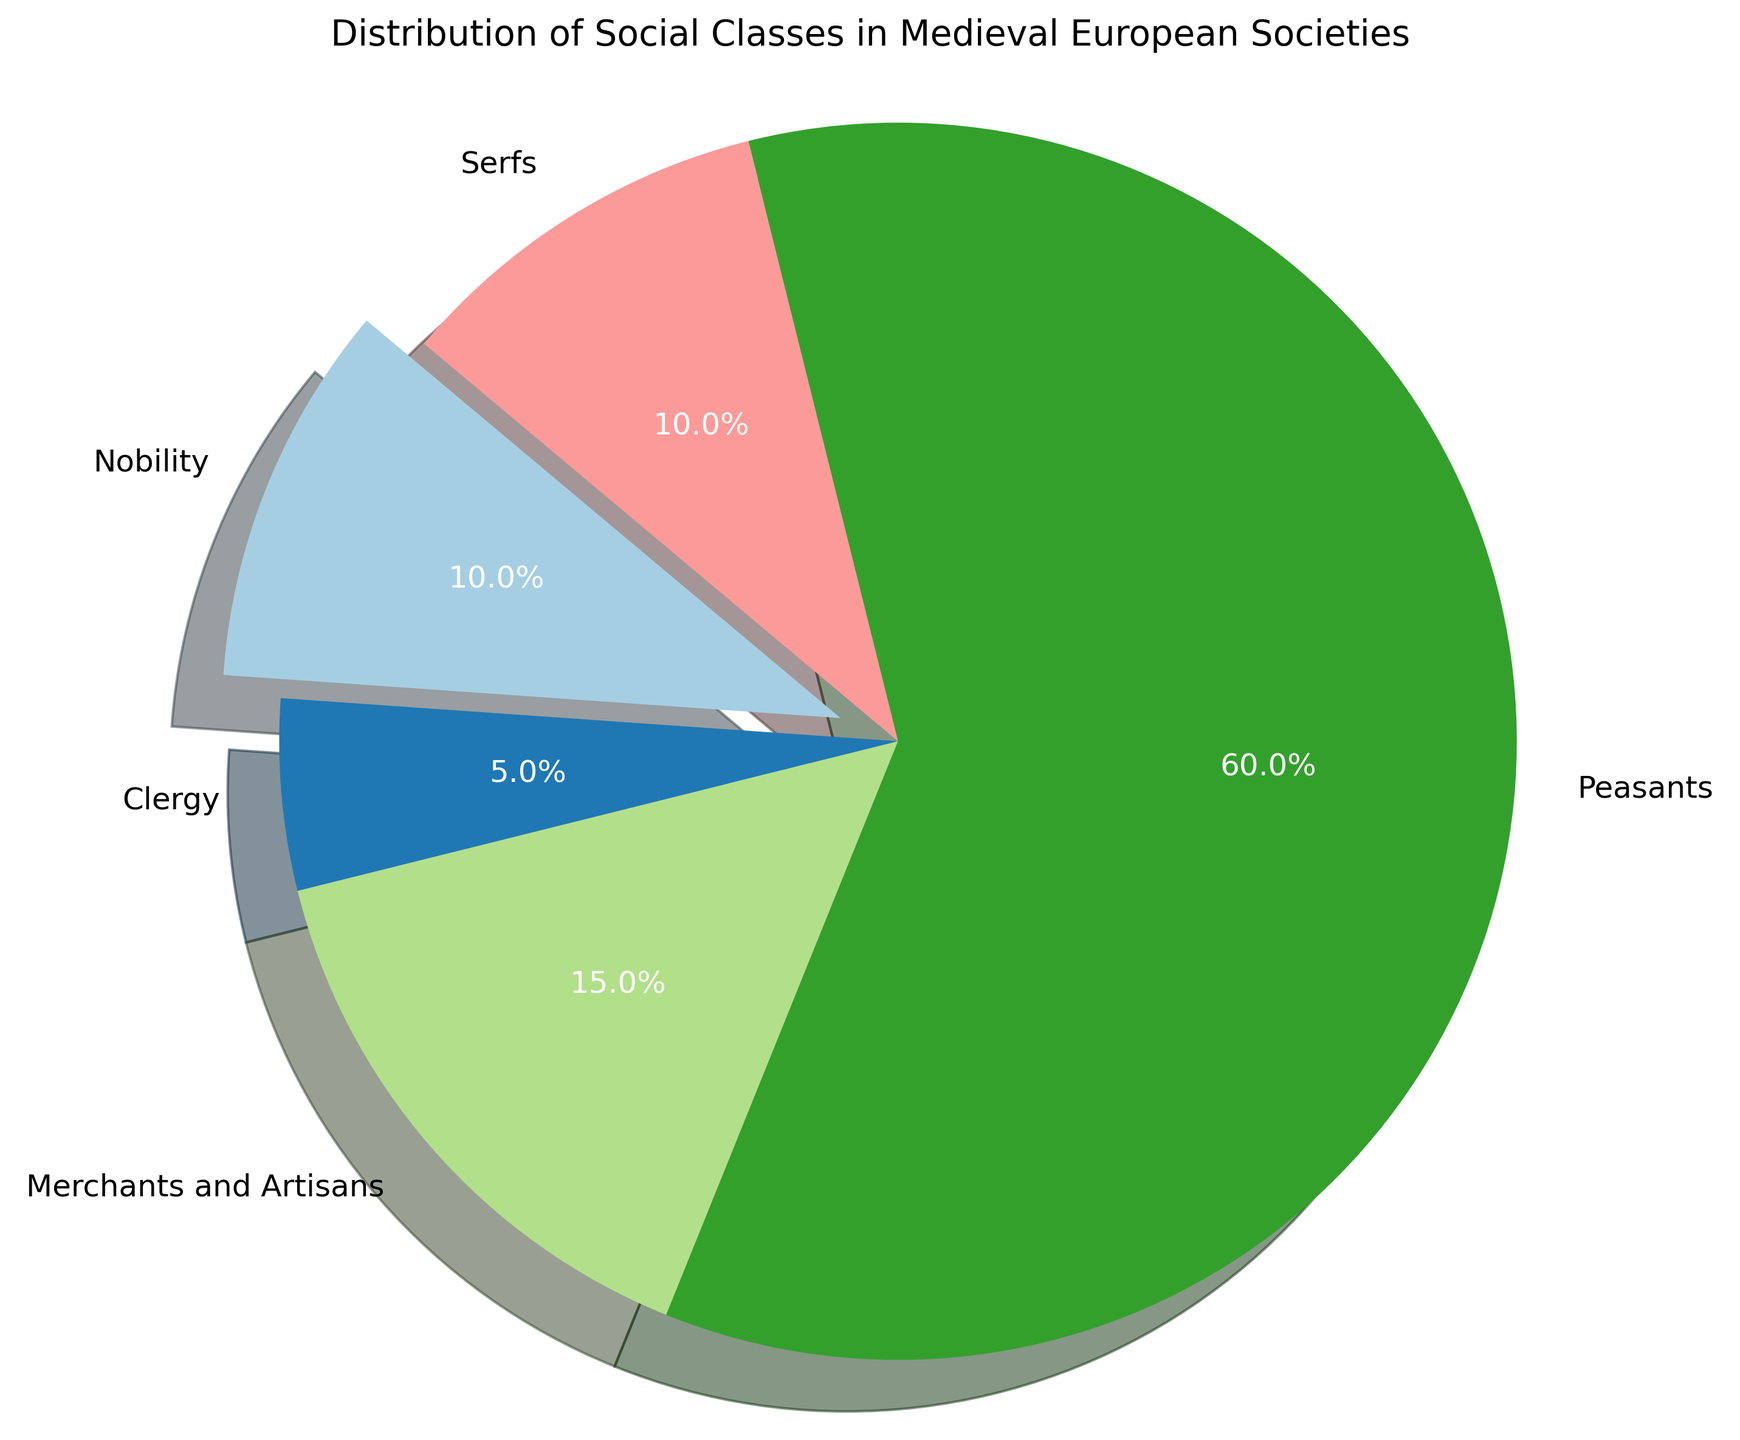Which social class has the highest percentage in the distribution? The figure shows that the 'Peasants' class occupies the largest portion of the pie chart. This indicates that they have the highest percentage in the distribution.
Answer: Peasants What is the combined percentage of Nobility and Serfs? To find the combined percentage, add the percentages of Nobility (10%) and Serfs (10%). 10% + 10% = 20%
Answer: 20% Which class occupies the smallest portion of the pie chart? By observing the sizes of the slices, the smallest portion is represented by 'Clergy', which is stated as 5%.
Answer: Clergy Which two classes have an equal percentage in the distribution? By comparing the sizes and labels, the 'Nobility' and 'Serfs' both have a percentage of 10%.
Answer: Nobility and Serfs How do the percentages of Merchants and Artisans compare to Clergy? Merchants and Artisans have 15%, whereas Clergy have only 5%. So, Merchants and Artisans have a higher percentage.
Answer: Merchants and Artisans have a higher percentage What percentage of the distribution is not made up of Peasants? To find this, subtract the percentage of Peasants (60%) from 100%. 100% - 60% = 40%
Answer: 40% How many times greater is the percentage of Peasants compared to Clergy? Peasants have 60% and Clergy have 5%. 60% divided by 5% equals 12.
Answer: 12 times Which class slice is visually emphasized in the pie chart and why? The 'Nobility' slice is visually emphasized as it is 'exploded' out from the pie chart.
Answer: Nobility is emphasized 